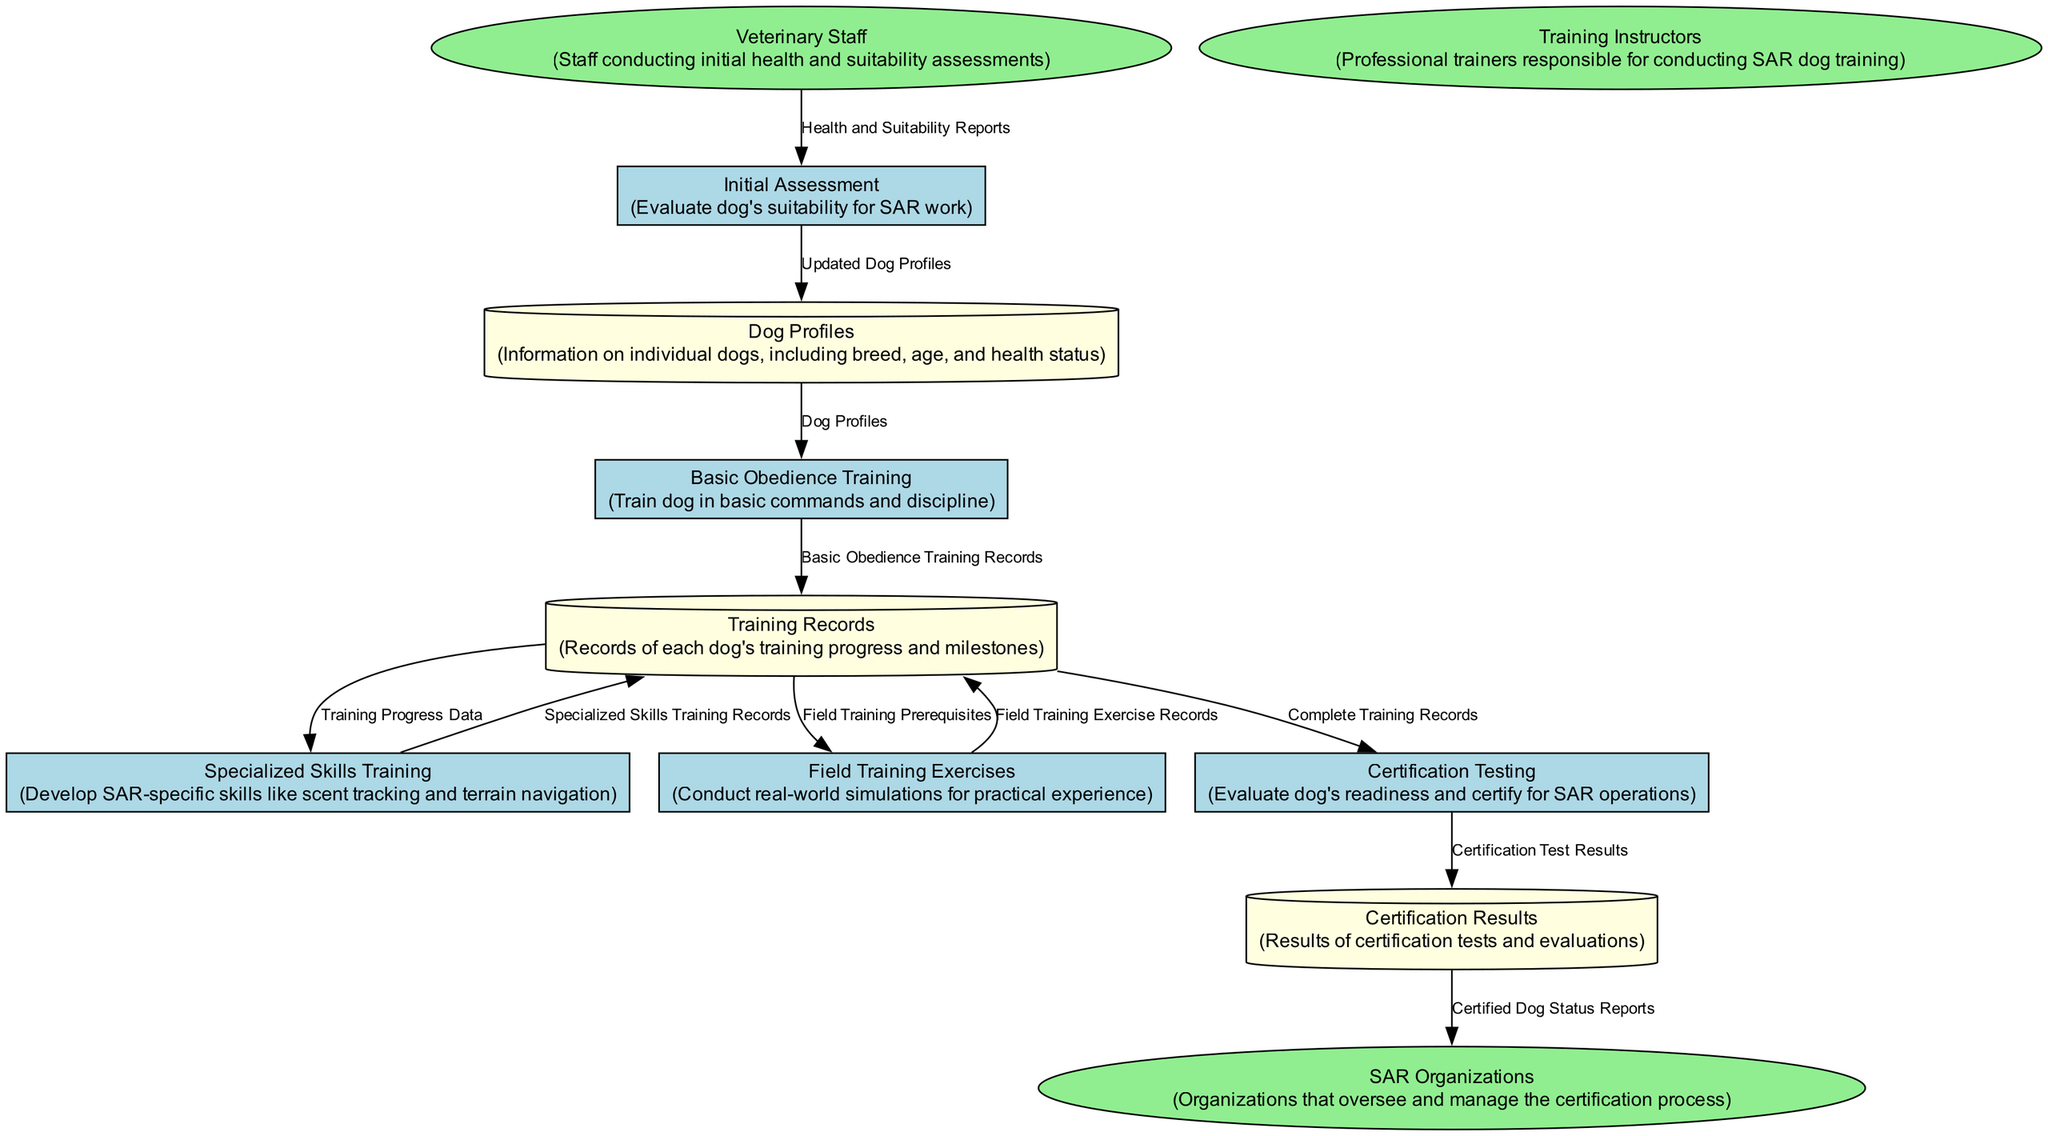What is the first process in the diagram? The first process listed in the diagram is "Initial Assessment". This is the first entry in the Processes section and is crucial as it determines if a dog is suitable for Search and Rescue work.
Answer: Initial Assessment What type of data does the "Dog Profiles" data store contain? The "Dog Profiles" data store contains information on individual dogs, including breed, age, and health status. This is explicitly stated in the content description of the data store.
Answer: Information on individual dogs How many data stores are in the diagram? There are three data stores listed in the diagram. They are "Dog Profiles", "Training Records", and "Certification Results". Counting them gives a total of three.
Answer: 3 Who provides the "Health and Suitability Reports" to the "Initial Assessment" process? The "Health and Suitability Reports" come from the "Veterinary Staff" entity. This flow is indicated in the Data Flows section where E2 connects to P1.
Answer: Veterinary Staff What is the output of the "Certification Testing" process? The output of the "Certification Testing" process is the "Certification Test Results", which are stored in the "Certification Results" data store according to the data flow indicated in the diagram.
Answer: Certification Test Results What happens to the records after "Basic Obedience Training"? After "Basic Obedience Training", the records are stored in "Training Records", as indicated by the flow from process P2 to data store DS2.
Answer: Stored in Training Records Which entity receives "Certified Dog Status Reports"? The "Certified Dog Status Reports" are sent to the "SAR Organizations" entity, as shown in the last data flow connecting DS3 to E3.
Answer: SAR Organizations How many processes collect records into data stores? There are five processes that collect records into data stores: processes P1, P2, P3, P4, and P5. Each of these processes either sends or updates records in the data stores.
Answer: 5 What type of training is conducted in the "Field Training Exercises" process? The "Field Training Exercises" process conducts real-world simulations for practical experience, as stated in the function description of that process.
Answer: Real-world simulations for practical experience 